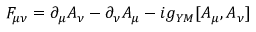<formula> <loc_0><loc_0><loc_500><loc_500>F _ { \mu \nu } = \partial _ { \mu } A _ { \nu } - \partial _ { \nu } A _ { \mu } - i g _ { Y M } [ A _ { \mu } , A _ { \nu } ]</formula> 